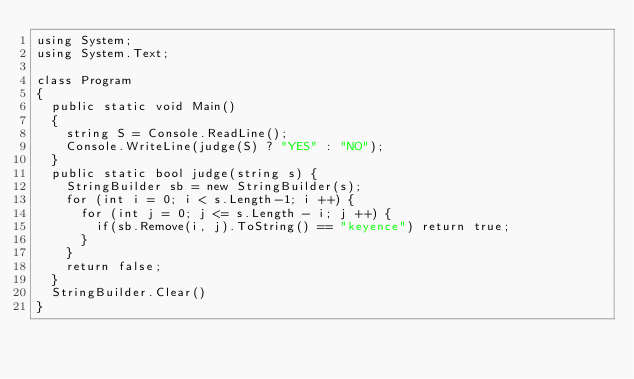<code> <loc_0><loc_0><loc_500><loc_500><_C#_>using System;
using System.Text;

class Program
{
  public static void Main()
  {
    string S = Console.ReadLine();
    Console.WriteLine(judge(S) ? "YES" : "NO");
  }
  public static bool judge(string s) {
    StringBuilder sb = new StringBuilder(s);
    for (int i = 0; i < s.Length-1; i ++) {
      for (int j = 0; j <= s.Length - i; j ++) {
        if(sb.Remove(i, j).ToString() == "keyence") return true;
      }
    }
    return false;
  }
  StringBuilder.Clear()
}</code> 